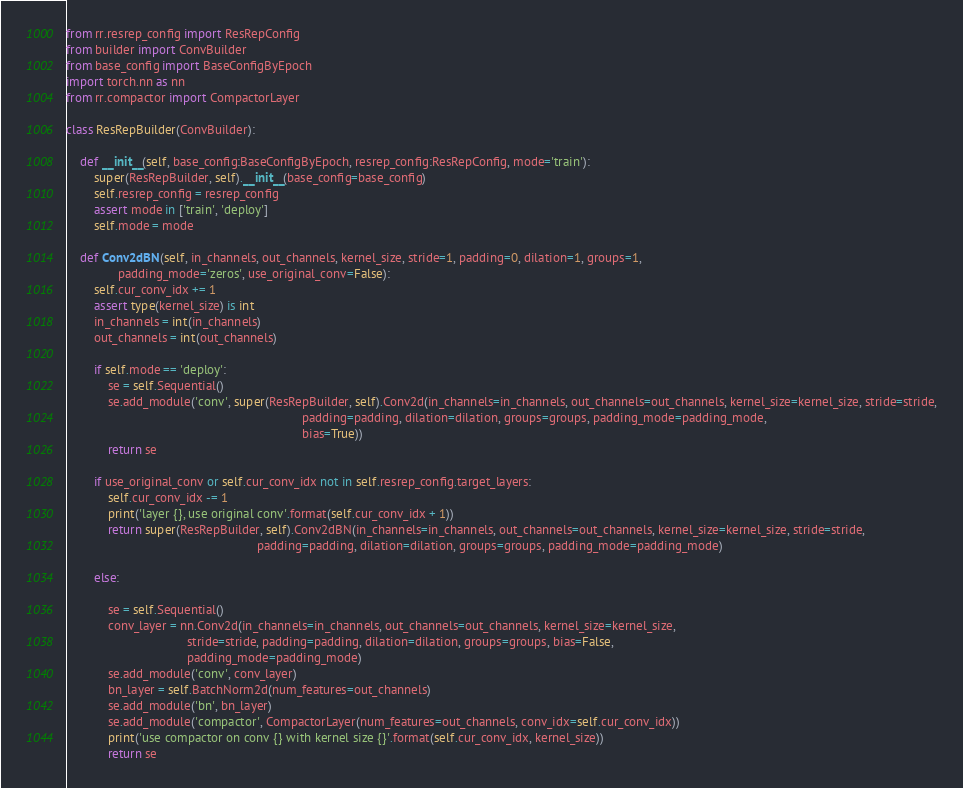Convert code to text. <code><loc_0><loc_0><loc_500><loc_500><_Python_>from rr.resrep_config import ResRepConfig
from builder import ConvBuilder
from base_config import BaseConfigByEpoch
import torch.nn as nn
from rr.compactor import CompactorLayer

class ResRepBuilder(ConvBuilder):

    def __init__(self, base_config:BaseConfigByEpoch, resrep_config:ResRepConfig, mode='train'):
        super(ResRepBuilder, self).__init__(base_config=base_config)
        self.resrep_config = resrep_config
        assert mode in ['train', 'deploy']
        self.mode = mode

    def Conv2dBN(self, in_channels, out_channels, kernel_size, stride=1, padding=0, dilation=1, groups=1,
               padding_mode='zeros', use_original_conv=False):
        self.cur_conv_idx += 1
        assert type(kernel_size) is int
        in_channels = int(in_channels)
        out_channels = int(out_channels)

        if self.mode == 'deploy':
            se = self.Sequential()
            se.add_module('conv', super(ResRepBuilder, self).Conv2d(in_channels=in_channels, out_channels=out_channels, kernel_size=kernel_size, stride=stride,
                                                                    padding=padding, dilation=dilation, groups=groups, padding_mode=padding_mode,
                                                                    bias=True))
            return se

        if use_original_conv or self.cur_conv_idx not in self.resrep_config.target_layers:
            self.cur_conv_idx -= 1
            print('layer {}, use original conv'.format(self.cur_conv_idx + 1))
            return super(ResRepBuilder, self).Conv2dBN(in_channels=in_channels, out_channels=out_channels, kernel_size=kernel_size, stride=stride,
                                                       padding=padding, dilation=dilation, groups=groups, padding_mode=padding_mode)

        else:

            se = self.Sequential()
            conv_layer = nn.Conv2d(in_channels=in_channels, out_channels=out_channels, kernel_size=kernel_size,
                                   stride=stride, padding=padding, dilation=dilation, groups=groups, bias=False,
                                   padding_mode=padding_mode)
            se.add_module('conv', conv_layer)
            bn_layer = self.BatchNorm2d(num_features=out_channels)
            se.add_module('bn', bn_layer)
            se.add_module('compactor', CompactorLayer(num_features=out_channels, conv_idx=self.cur_conv_idx))
            print('use compactor on conv {} with kernel size {}'.format(self.cur_conv_idx, kernel_size))
            return se</code> 